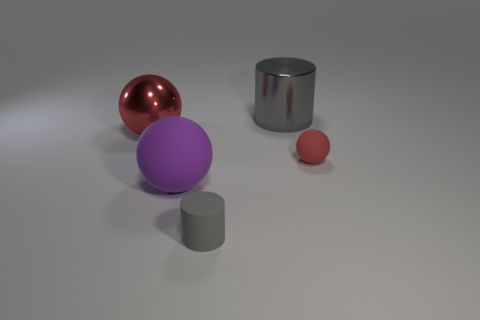How many objects are big blue rubber objects or small rubber objects that are on the left side of the big gray cylinder? Upon examining the image, we can see that there are no big blue rubber objects. However, there is one small red rubber ball to the left side of the big gray cylinder. Therefore, considering the criteria, there is only one small rubber object that fits the description. 